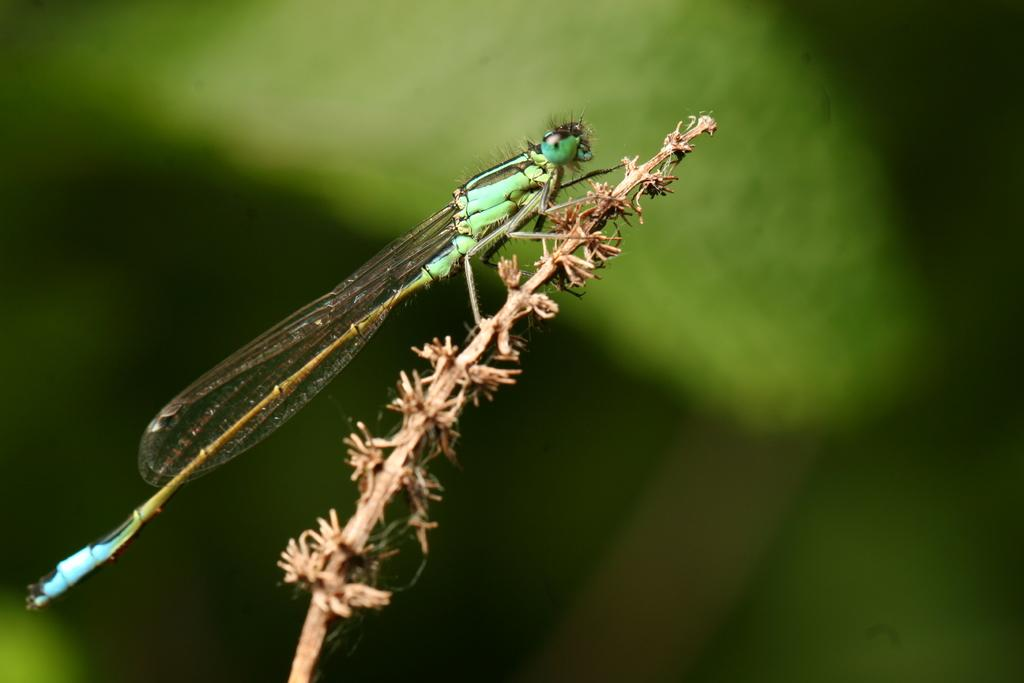What is the main subject of the image? There is a dragonfly in the image. What is the dragonfly resting on? The dragonfly is on a stick. Can you describe the background of the image? The background of the image is blurred. What type of glove is the dragonfly wearing in the image? There is no glove present in the image, and dragonflies do not wear gloves. 